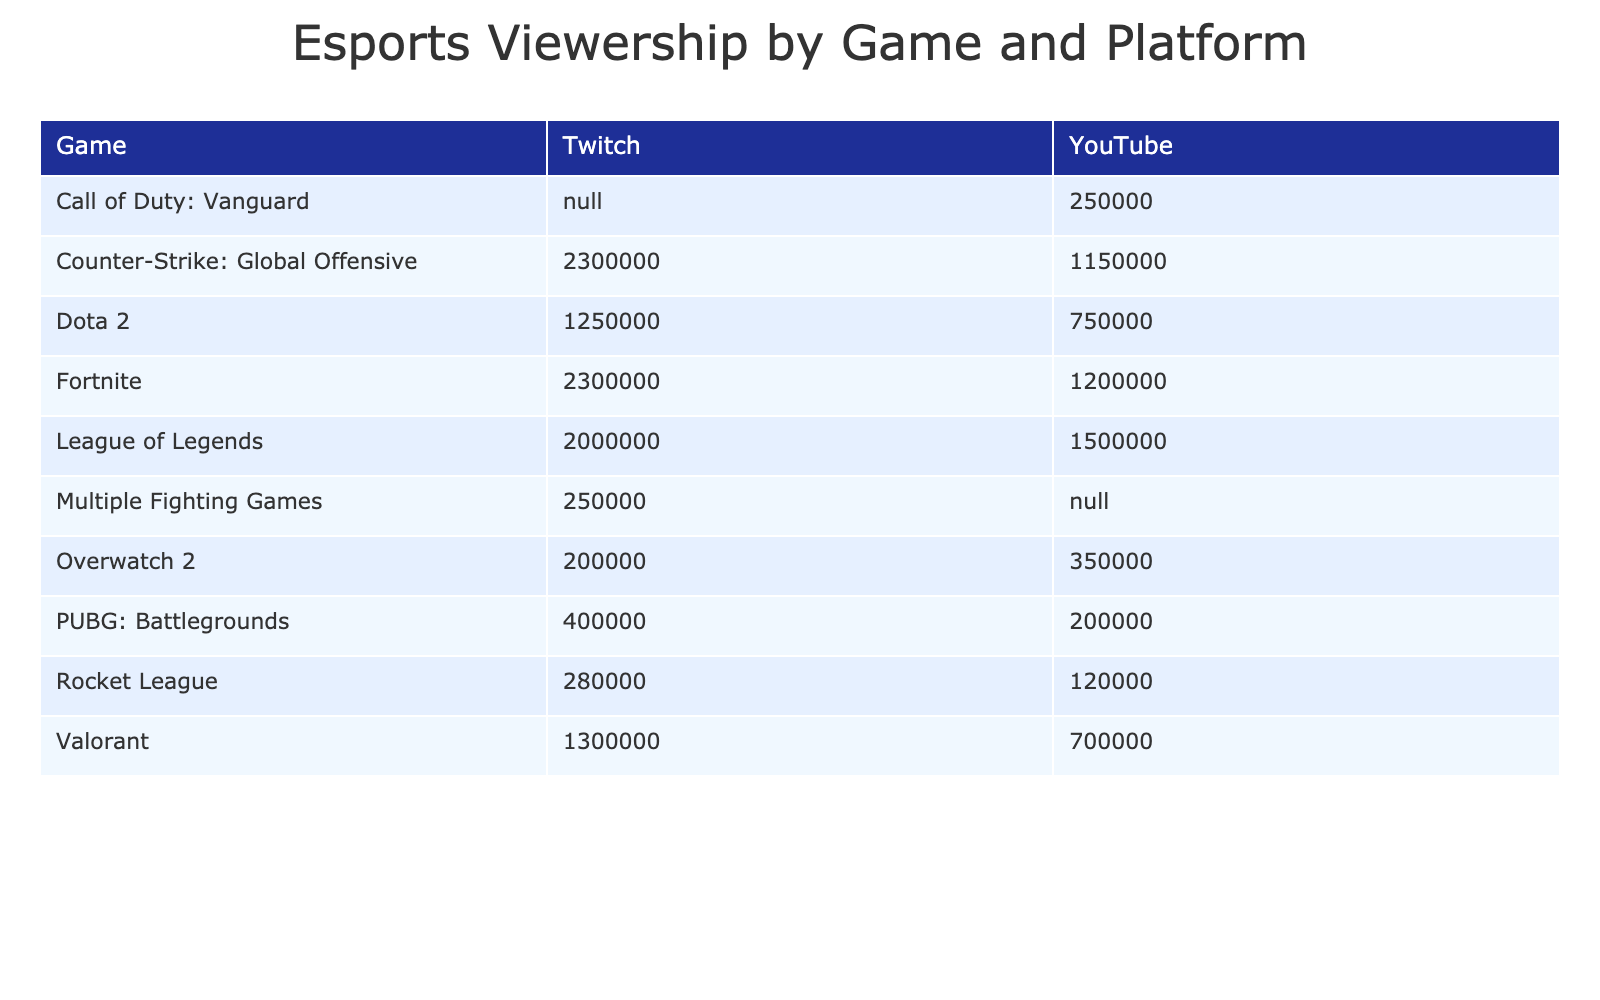What event had the highest total viewership on Twitch? The total viewership for each event on Twitch can be found in the table. The International 2022 had 1,250,000 viewers, League of Legends Worlds 2022 had 2,000,000 viewers, CSGO Major Stockholm 2021 had 1,800,000 viewers, Valorant Champions 2022 had 1,300,000 viewers, and Fortnite World Cup 2019 had 2,300,000 viewers. Comparing these values, Fortnite World Cup 2019 had the highest total viewership on Twitch with 2,300,000 viewers.
Answer: Fortnite World Cup 2019 How many total viewers did League of Legends Worlds 2022 receive across both platforms? To find the total viewership for League of Legends Worlds 2022, sum the viewers from both platforms. On Twitch, there were 2,000,000 viewers and on YouTube 1,500,000 viewers. Therefore, total viewers = 2,000,000 + 1,500,000 = 3,500,000.
Answer: 3,500,000 Was there an Esports event in 2022 that had more viewers on YouTube than on Twitch? We need to compare the viewership numbers for each event in 2022 on both platforms. For League of Legends Worlds 2022, YouTube (1,500,000) had more viewers than Twitch (2,000,000). For Overwatch League Grand Finals 2022, YouTube (350,000) had more viewers than Twitch (200,000). For Valorant Champions 2022, YouTube (700,000) had fewer viewers than Twitch (1,300,000). Thus, Overwatch League Grand Finals 2022 is the only event in 2022 where YouTube had more viewers than Twitch.
Answer: Yes What is the average number of peak concurrent viewers for CSGO Major Stockholm 2021 across both platforms? To calculate the average peak concurrent viewers for CSGO Major Stockholm 2021, first, obtain the peak concurrent viewers from both platforms: Twitch has 2,200,000 and YouTube has 1,100,000. Next, sum these values and divide by the number of platforms: (2,200,000 + 1,100,000) / 2 = 1,650,000.
Answer: 1,650,000 Which game had the lowest total viewers on Twitch? Looking at the viewership numbers on Twitch, the following viewer totals were recorded: Dota 2 (1,250,000), League of Legends (2,000,000), CSGO (1,800,000), Valorant (1,300,000), Overwatch 2 (200,000), ESL Pro League Season 16 (500,000), Rocket League (280,000), PUBG (400,000), Call of Duty: Vanguard (0), Fortnite (2,300,000), and EVO 2022 (250,000). Among these, Overwatch 2 had the lowest total viewers with 200,000.
Answer: Overwatch 2 